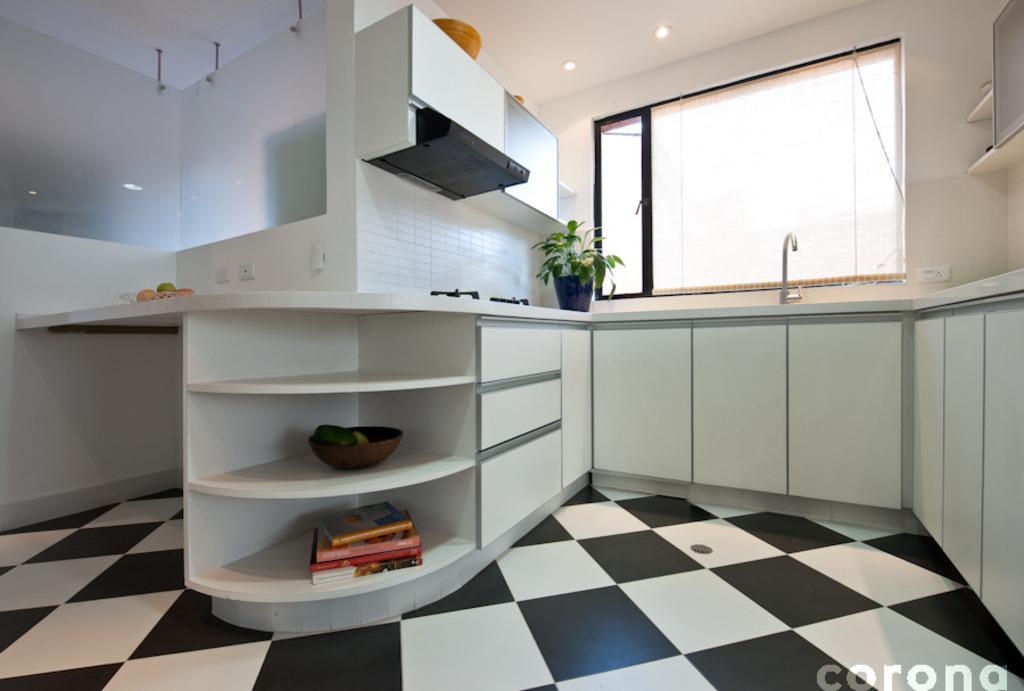Could you give a brief overview of what you see in this image? In this image there is a modular kitchen. There is a stove. There is a chimney. There are books. There is a glass window. There is marble floor. There are cupboards. 